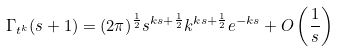<formula> <loc_0><loc_0><loc_500><loc_500>\Gamma _ { t ^ { k } } ( s + 1 ) & = ( 2 \pi ) ^ { \frac { 1 } { 2 } } s ^ { k s + \frac { 1 } { 2 } } k ^ { k s + \frac { 1 } { 2 } } e ^ { - k s } + O \left ( \frac { 1 } { s } \right )</formula> 